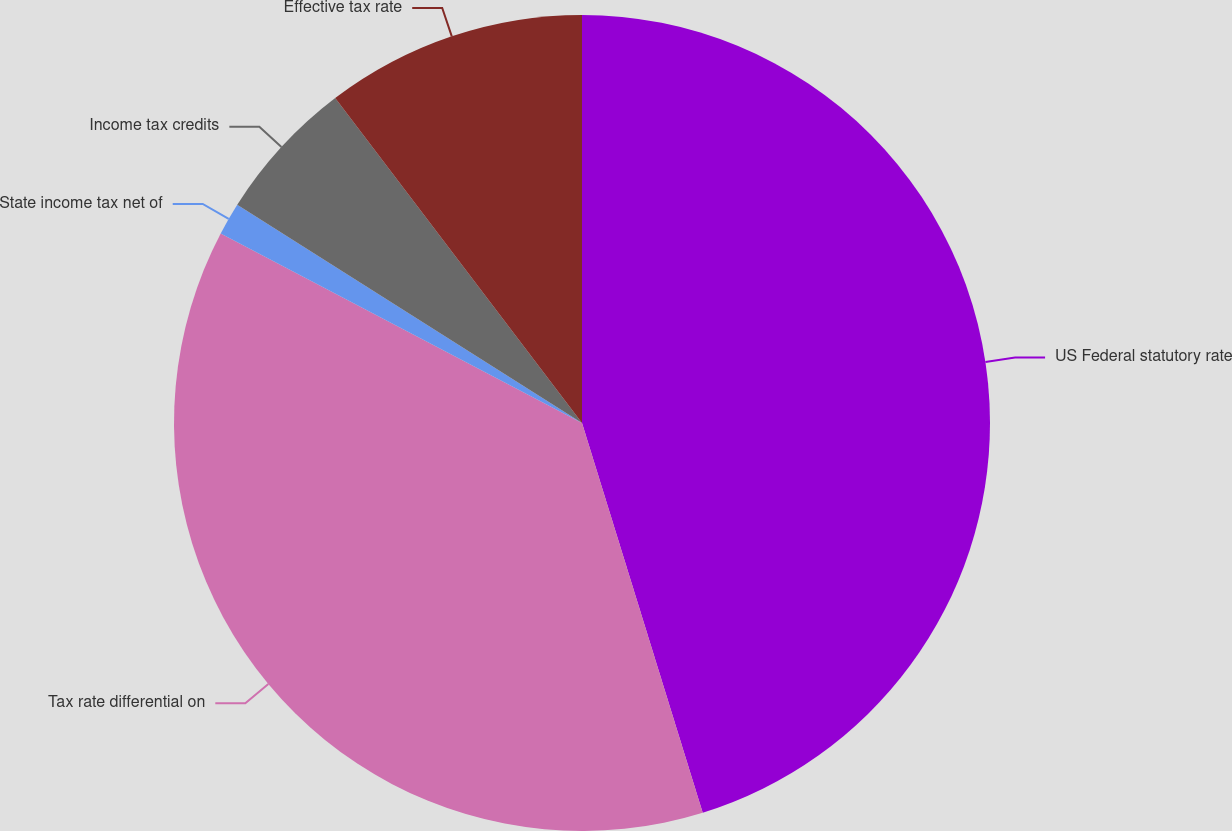Convert chart. <chart><loc_0><loc_0><loc_500><loc_500><pie_chart><fcel>US Federal statutory rate<fcel>Tax rate differential on<fcel>State income tax net of<fcel>Income tax credits<fcel>Effective tax rate<nl><fcel>45.22%<fcel>37.47%<fcel>1.29%<fcel>5.68%<fcel>10.34%<nl></chart> 